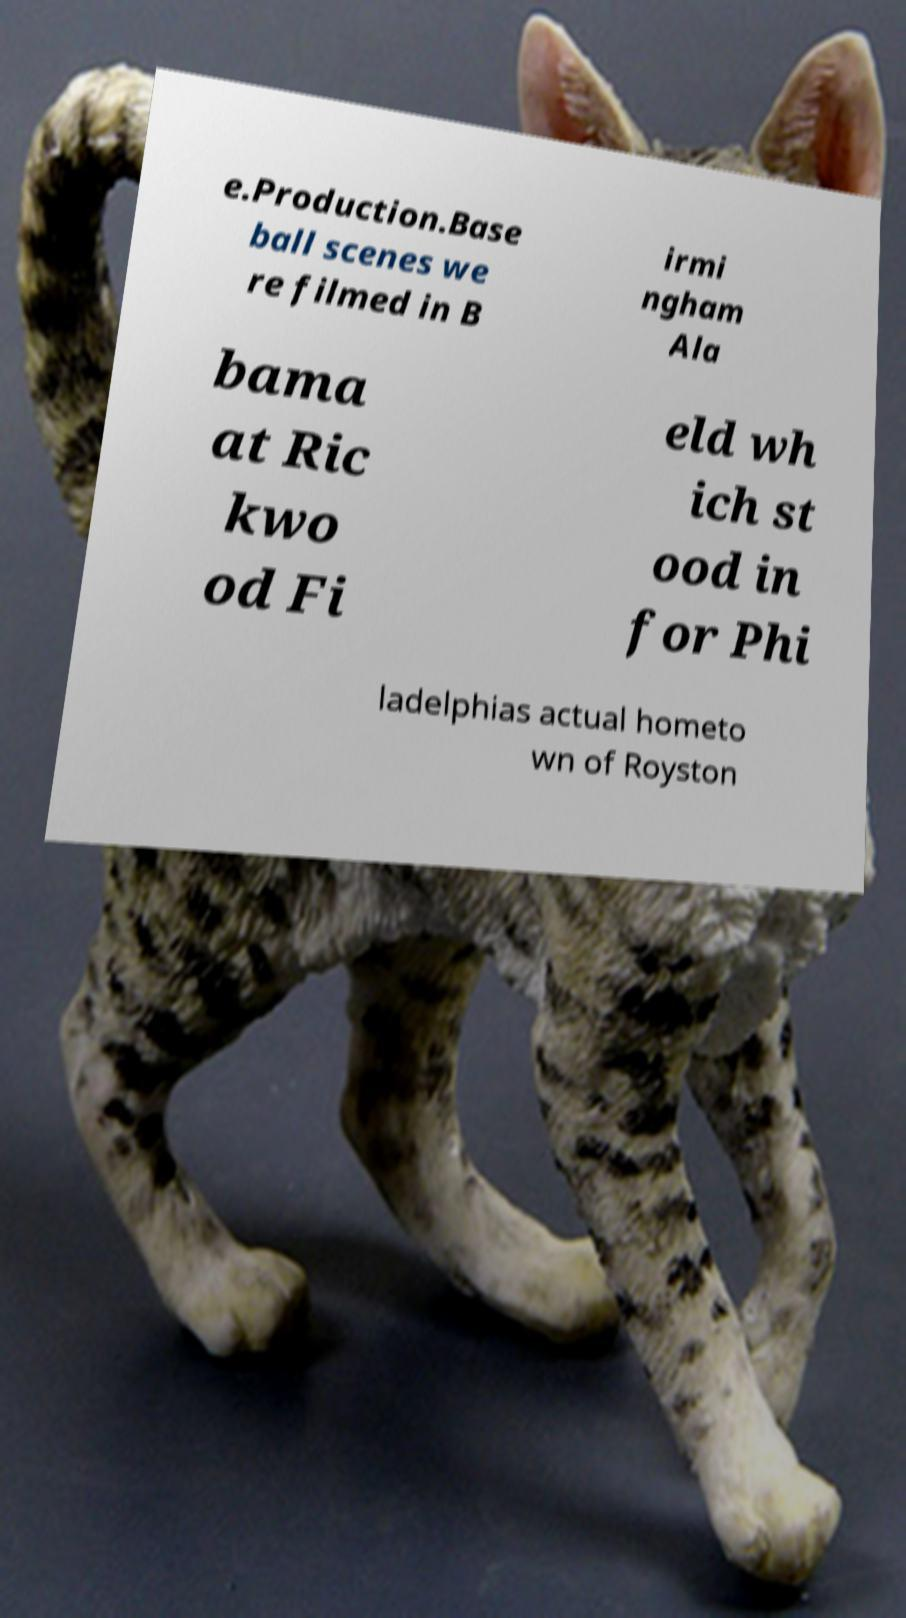Can you accurately transcribe the text from the provided image for me? e.Production.Base ball scenes we re filmed in B irmi ngham Ala bama at Ric kwo od Fi eld wh ich st ood in for Phi ladelphias actual hometo wn of Royston 